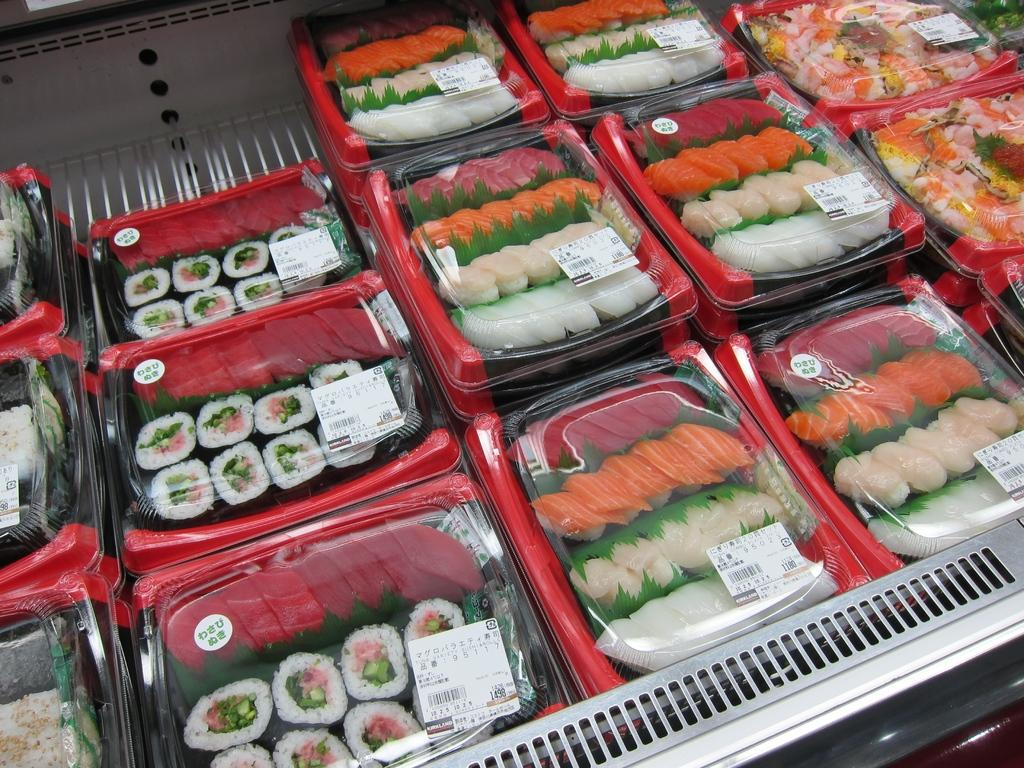What types of items are in the center of the image? There are foods in the center of the image. Can you describe the arrangement of the foods in the image? The foods are in the center of the image. What is the historical significance of the position of the foods in the image? There is no historical significance associated with the position of the foods in the image. 